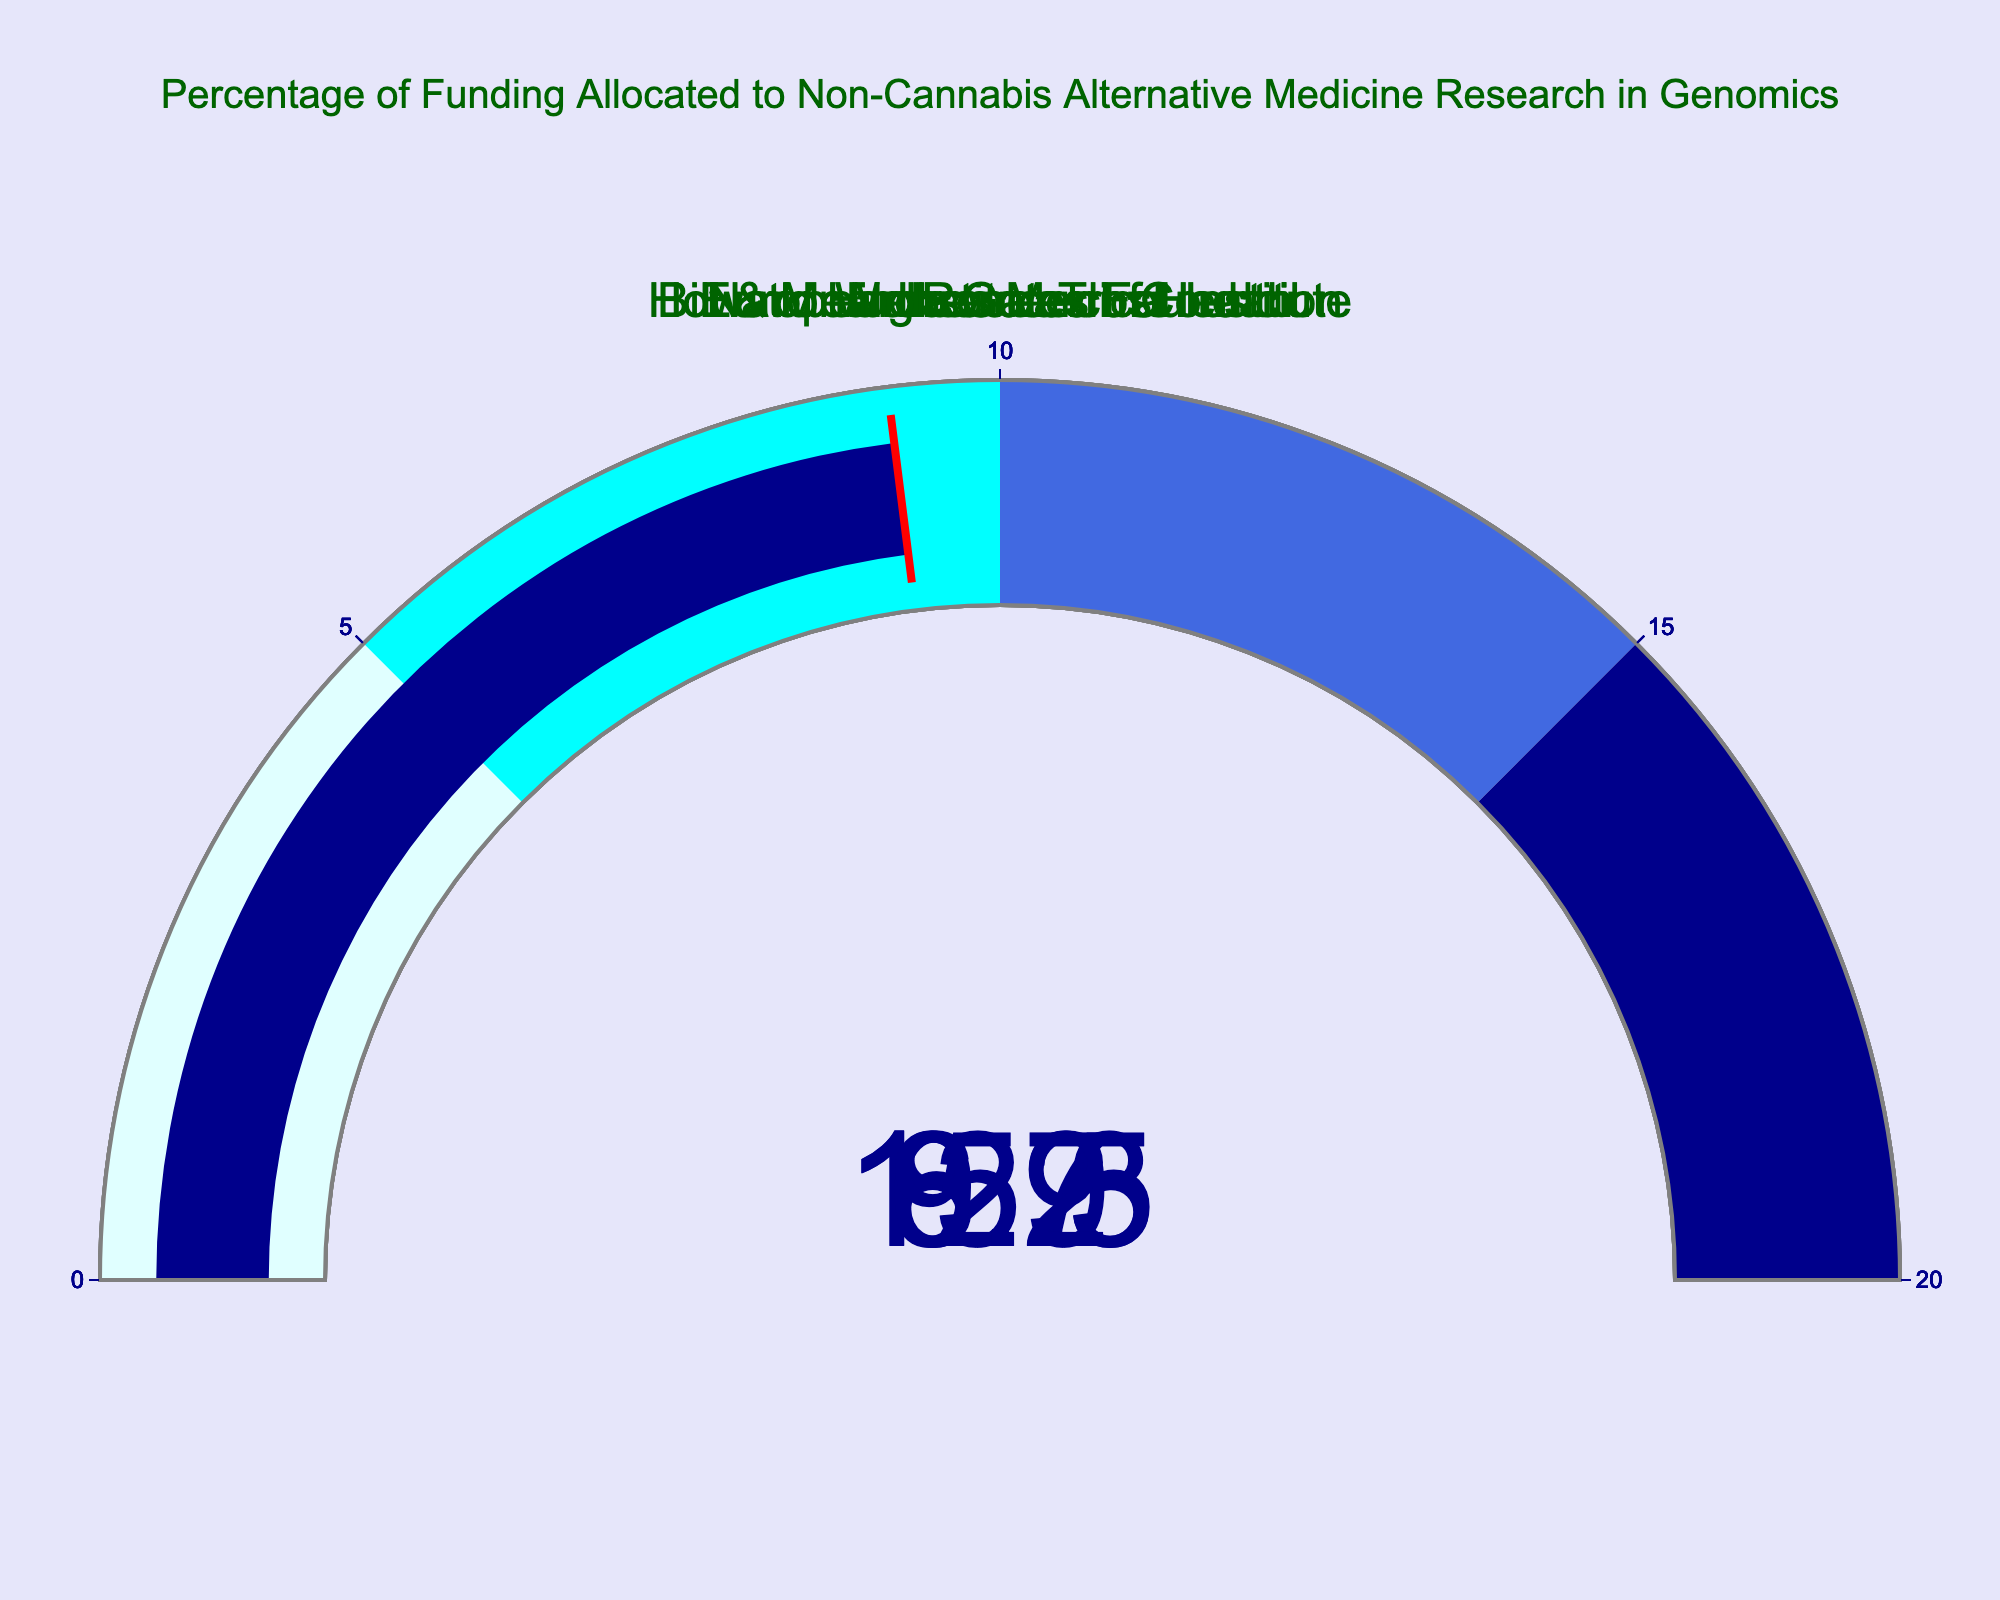What's the percentage of funding allocated by the Wellcome Trust? Look at the gauge chart representing the Wellcome Trust. The dial points to 15.3%.
Answer: 15.3% Which funding source allocates the highest percentage to non-cannabis alternative medicine research? Compare the values indicated by each funding source's gauge. The highest value is from the Wellcome Trust at 15.3%.
Answer: Wellcome Trust What is the total percentage of funding allocated by National Institutes of Health and European Research Council combined? Add the percentages of the National Institutes of Health (12.5%) and the European Research Council (8.7%). The total is 12.5 + 8.7 = 21.2%.
Answer: 21.2% How much lower is the percentage of funding from the Bill & Melinda Gates Foundation compared to the Wellcome Trust? Subtract the percentage of the Bill & Melinda Gates Foundation (9.2%) from the Wellcome Trust (15.3%). The difference is 15.3 - 9.2 = 6.1%.
Answer: 6.1% Which funding source allocates the smallest percentage to non-cannabis alternative medicine research? Compare the values indicated by each funding source's gauge. The lowest value is from the Howard Hughes Medical Institute at 6.9%.
Answer: Howard Hughes Medical Institute How many funding sources allocate more than 10% to non-cannabis alternative medicine research? Count the funding sources with values greater than 10%. The Wellcome Trust (15.3%) and National Institutes of Health (12.5%) are the only sources above 10%. There are 2 funding sources.
Answer: 2 What is the average percentage of funding allocated by all sources? Find the sum of all the percentages and divide by the number of sources: (12.5 + 8.7 + 15.3 + 6.9 + 9.2) / 5 = 52.6 / 5 = 10.52%.
Answer: 10.52% Does any funding source exceed the 20% threshold mark on the gauge chart? Review the values on each gauge chart; none exceed 20%, with the highest being the Wellcome Trust at 15.3%.
Answer: No If Howard Hughes Medical Institute were to double its funding allocation percentage, would it surpass the National Institutes of Health? Double the Howard Hughes Medical Institute's percentage (6.9% * 2 = 13.8%). Compare this with the National Institutes of Health's 12.5%. Since 13.8% is greater than 12.5%, it would surpass.
Answer: Yes 